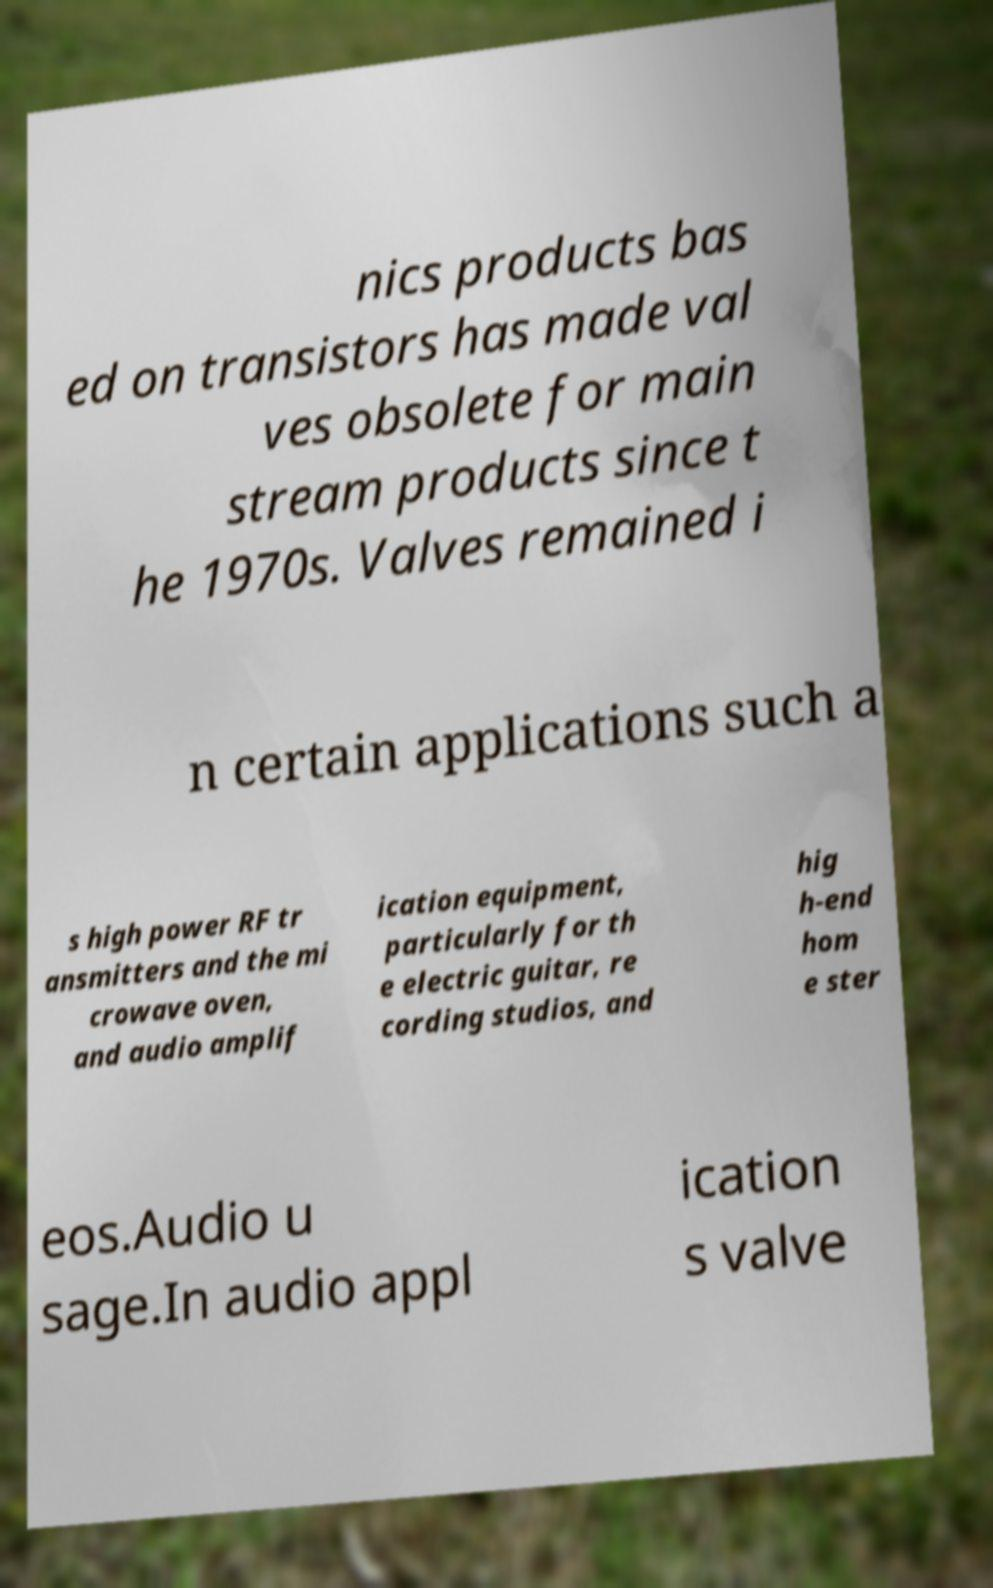Please read and relay the text visible in this image. What does it say? nics products bas ed on transistors has made val ves obsolete for main stream products since t he 1970s. Valves remained i n certain applications such a s high power RF tr ansmitters and the mi crowave oven, and audio amplif ication equipment, particularly for th e electric guitar, re cording studios, and hig h-end hom e ster eos.Audio u sage.In audio appl ication s valve 